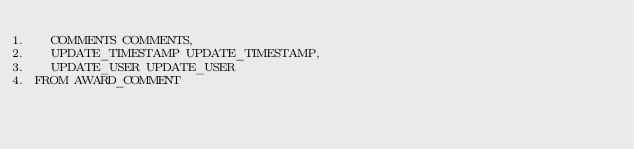<code> <loc_0><loc_0><loc_500><loc_500><_SQL_>	COMMENTS COMMENTS,
	UPDATE_TIMESTAMP UPDATE_TIMESTAMP, 
	UPDATE_USER UPDATE_USER
FROM AWARD_COMMENT</code> 